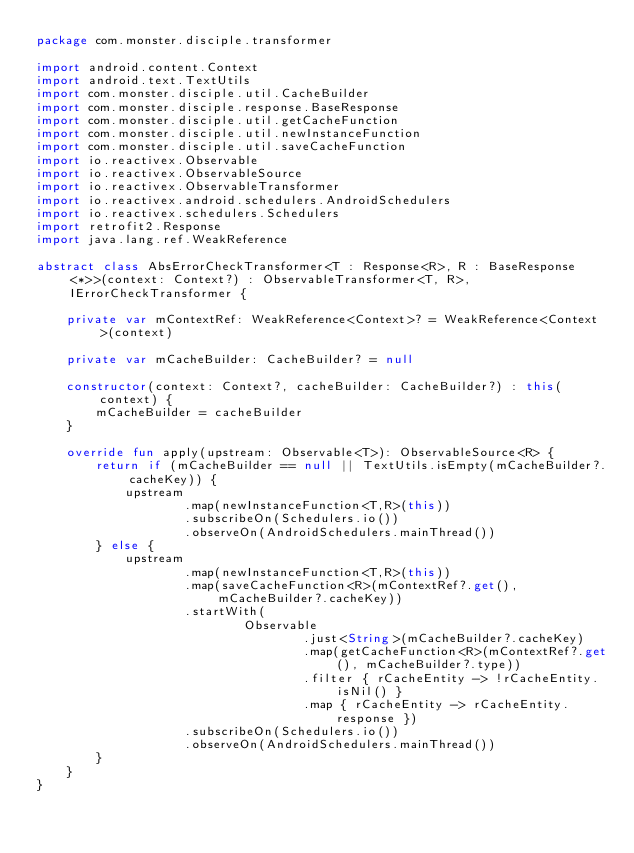Convert code to text. <code><loc_0><loc_0><loc_500><loc_500><_Kotlin_>package com.monster.disciple.transformer

import android.content.Context
import android.text.TextUtils
import com.monster.disciple.util.CacheBuilder
import com.monster.disciple.response.BaseResponse
import com.monster.disciple.util.getCacheFunction
import com.monster.disciple.util.newInstanceFunction
import com.monster.disciple.util.saveCacheFunction
import io.reactivex.Observable
import io.reactivex.ObservableSource
import io.reactivex.ObservableTransformer
import io.reactivex.android.schedulers.AndroidSchedulers
import io.reactivex.schedulers.Schedulers
import retrofit2.Response
import java.lang.ref.WeakReference

abstract class AbsErrorCheckTransformer<T : Response<R>, R : BaseResponse<*>>(context: Context?) : ObservableTransformer<T, R>, IErrorCheckTransformer {

    private var mContextRef: WeakReference<Context>? = WeakReference<Context>(context)

    private var mCacheBuilder: CacheBuilder? = null

    constructor(context: Context?, cacheBuilder: CacheBuilder?) : this(context) {
        mCacheBuilder = cacheBuilder
    }

    override fun apply(upstream: Observable<T>): ObservableSource<R> {
        return if (mCacheBuilder == null || TextUtils.isEmpty(mCacheBuilder?.cacheKey)) {
            upstream
                    .map(newInstanceFunction<T,R>(this))
                    .subscribeOn(Schedulers.io())
                    .observeOn(AndroidSchedulers.mainThread())
        } else {
            upstream
                    .map(newInstanceFunction<T,R>(this))
                    .map(saveCacheFunction<R>(mContextRef?.get(), mCacheBuilder?.cacheKey))
                    .startWith(
                            Observable
                                    .just<String>(mCacheBuilder?.cacheKey)
                                    .map(getCacheFunction<R>(mContextRef?.get(), mCacheBuilder?.type))
                                    .filter { rCacheEntity -> !rCacheEntity.isNil() }
                                    .map { rCacheEntity -> rCacheEntity.response })
                    .subscribeOn(Schedulers.io())
                    .observeOn(AndroidSchedulers.mainThread())
        }
    }
}

</code> 